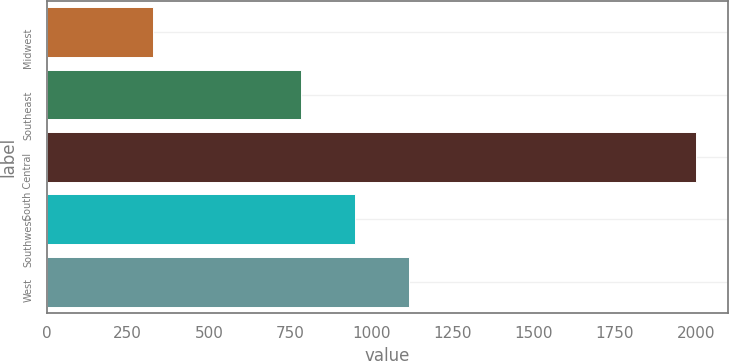<chart> <loc_0><loc_0><loc_500><loc_500><bar_chart><fcel>Midwest<fcel>Southeast<fcel>South Central<fcel>Southwest<fcel>West<nl><fcel>328<fcel>783<fcel>1999<fcel>950.1<fcel>1117.2<nl></chart> 